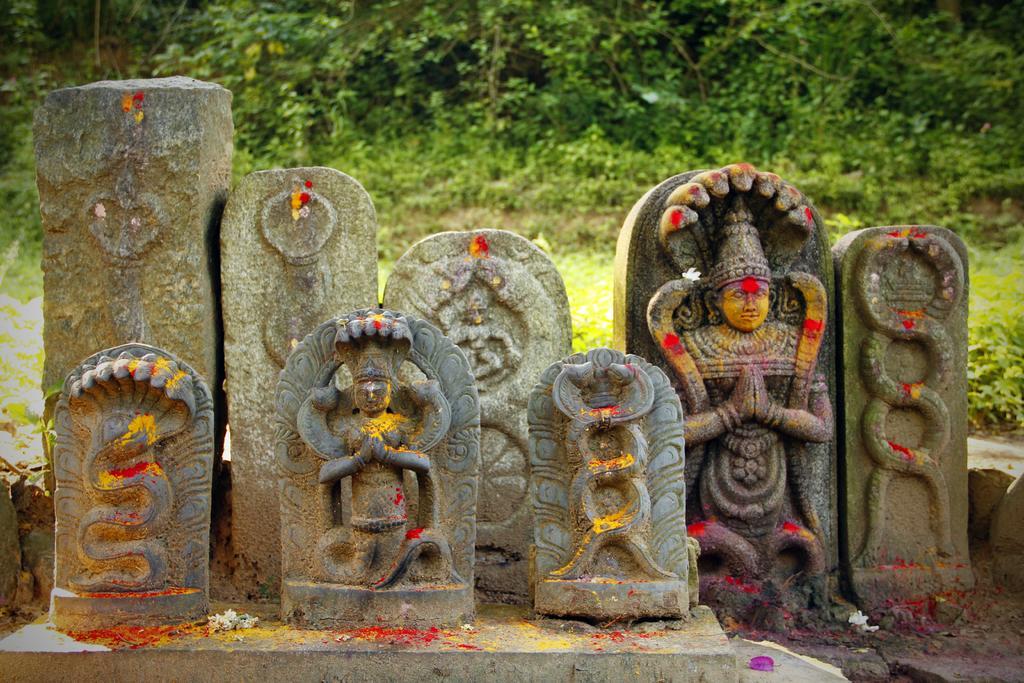How would you summarize this image in a sentence or two? In this image we can see some sculptures. And in the background, we can see some trees. 